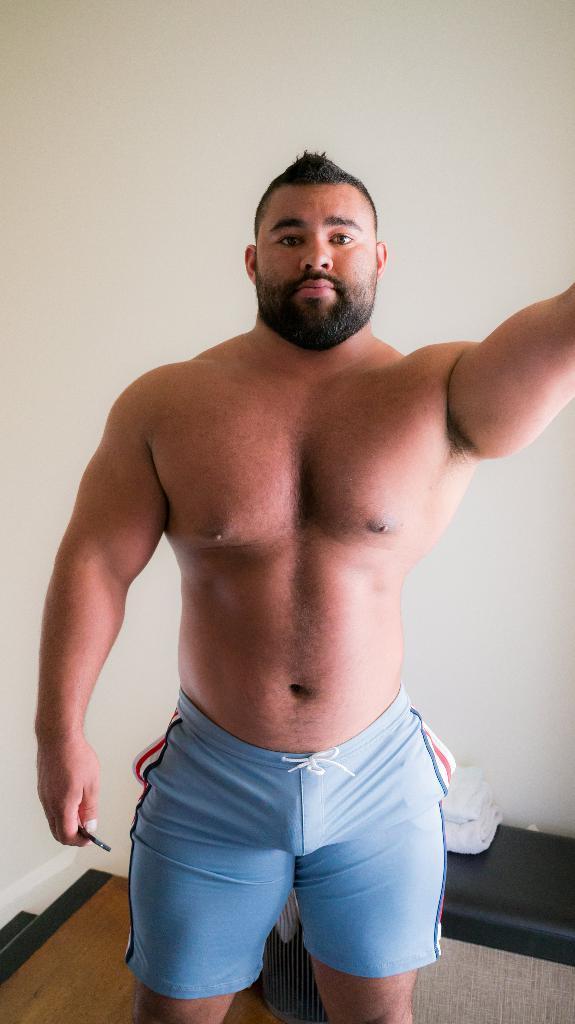Could you give a brief overview of what you see in this image? In this image we can see a person. In the background of the image there is a wall. At the bottom of the image there is wooden flooring. 